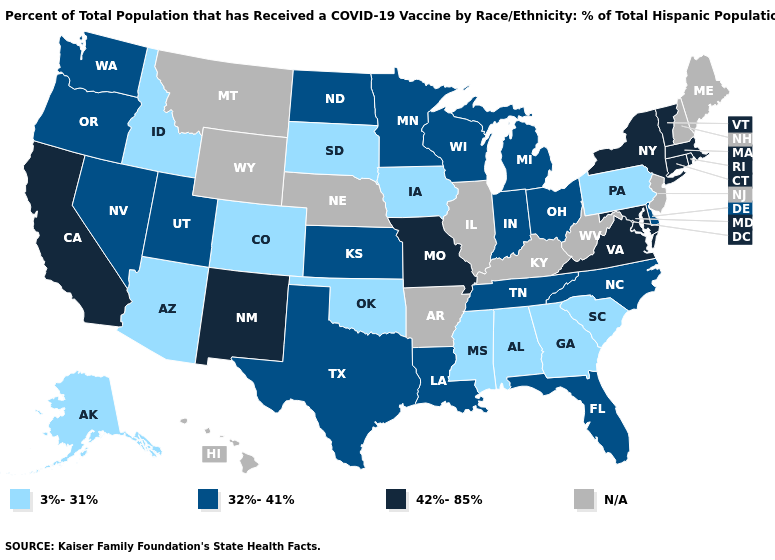Name the states that have a value in the range 32%-41%?
Concise answer only. Delaware, Florida, Indiana, Kansas, Louisiana, Michigan, Minnesota, Nevada, North Carolina, North Dakota, Ohio, Oregon, Tennessee, Texas, Utah, Washington, Wisconsin. What is the value of Illinois?
Short answer required. N/A. Which states have the lowest value in the USA?
Concise answer only. Alabama, Alaska, Arizona, Colorado, Georgia, Idaho, Iowa, Mississippi, Oklahoma, Pennsylvania, South Carolina, South Dakota. Among the states that border Alabama , which have the highest value?
Be succinct. Florida, Tennessee. What is the value of Oregon?
Answer briefly. 32%-41%. Among the states that border North Carolina , does Tennessee have the lowest value?
Concise answer only. No. Name the states that have a value in the range 42%-85%?
Answer briefly. California, Connecticut, Maryland, Massachusetts, Missouri, New Mexico, New York, Rhode Island, Vermont, Virginia. Does Kansas have the lowest value in the USA?
Answer briefly. No. What is the value of Nebraska?
Write a very short answer. N/A. Among the states that border Kentucky , which have the lowest value?
Keep it brief. Indiana, Ohio, Tennessee. Among the states that border Vermont , which have the lowest value?
Answer briefly. Massachusetts, New York. Name the states that have a value in the range 3%-31%?
Keep it brief. Alabama, Alaska, Arizona, Colorado, Georgia, Idaho, Iowa, Mississippi, Oklahoma, Pennsylvania, South Carolina, South Dakota. Does Ohio have the highest value in the USA?
Concise answer only. No. Does Missouri have the highest value in the USA?
Answer briefly. Yes. What is the value of Michigan?
Short answer required. 32%-41%. 